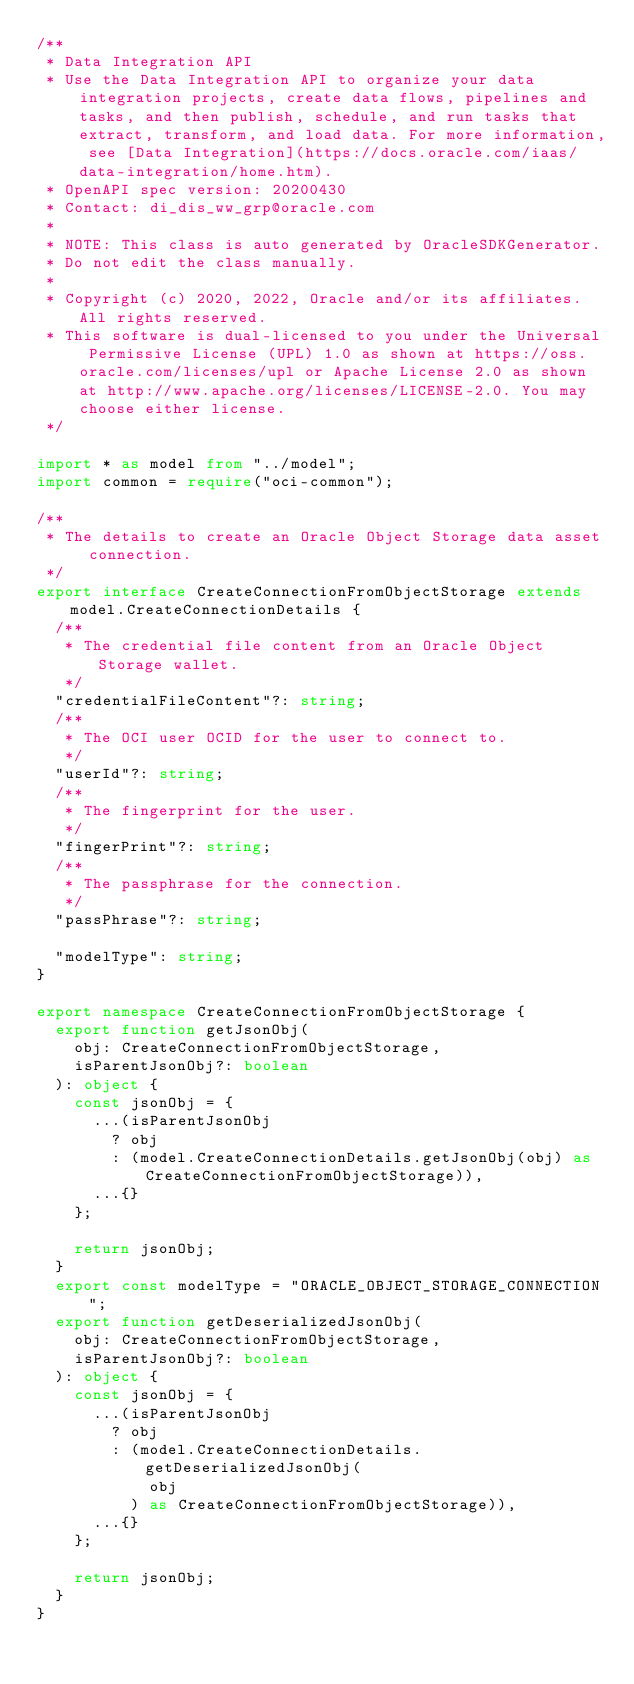Convert code to text. <code><loc_0><loc_0><loc_500><loc_500><_TypeScript_>/**
 * Data Integration API
 * Use the Data Integration API to organize your data integration projects, create data flows, pipelines and tasks, and then publish, schedule, and run tasks that extract, transform, and load data. For more information, see [Data Integration](https://docs.oracle.com/iaas/data-integration/home.htm).
 * OpenAPI spec version: 20200430
 * Contact: di_dis_ww_grp@oracle.com
 *
 * NOTE: This class is auto generated by OracleSDKGenerator.
 * Do not edit the class manually.
 *
 * Copyright (c) 2020, 2022, Oracle and/or its affiliates.  All rights reserved.
 * This software is dual-licensed to you under the Universal Permissive License (UPL) 1.0 as shown at https://oss.oracle.com/licenses/upl or Apache License 2.0 as shown at http://www.apache.org/licenses/LICENSE-2.0. You may choose either license.
 */

import * as model from "../model";
import common = require("oci-common");

/**
 * The details to create an Oracle Object Storage data asset connection.
 */
export interface CreateConnectionFromObjectStorage extends model.CreateConnectionDetails {
  /**
   * The credential file content from an Oracle Object Storage wallet.
   */
  "credentialFileContent"?: string;
  /**
   * The OCI user OCID for the user to connect to.
   */
  "userId"?: string;
  /**
   * The fingerprint for the user.
   */
  "fingerPrint"?: string;
  /**
   * The passphrase for the connection.
   */
  "passPhrase"?: string;

  "modelType": string;
}

export namespace CreateConnectionFromObjectStorage {
  export function getJsonObj(
    obj: CreateConnectionFromObjectStorage,
    isParentJsonObj?: boolean
  ): object {
    const jsonObj = {
      ...(isParentJsonObj
        ? obj
        : (model.CreateConnectionDetails.getJsonObj(obj) as CreateConnectionFromObjectStorage)),
      ...{}
    };

    return jsonObj;
  }
  export const modelType = "ORACLE_OBJECT_STORAGE_CONNECTION";
  export function getDeserializedJsonObj(
    obj: CreateConnectionFromObjectStorage,
    isParentJsonObj?: boolean
  ): object {
    const jsonObj = {
      ...(isParentJsonObj
        ? obj
        : (model.CreateConnectionDetails.getDeserializedJsonObj(
            obj
          ) as CreateConnectionFromObjectStorage)),
      ...{}
    };

    return jsonObj;
  }
}
</code> 